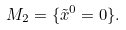<formula> <loc_0><loc_0><loc_500><loc_500>M _ { 2 } = \{ \tilde { x } ^ { 0 } = 0 \} .</formula> 